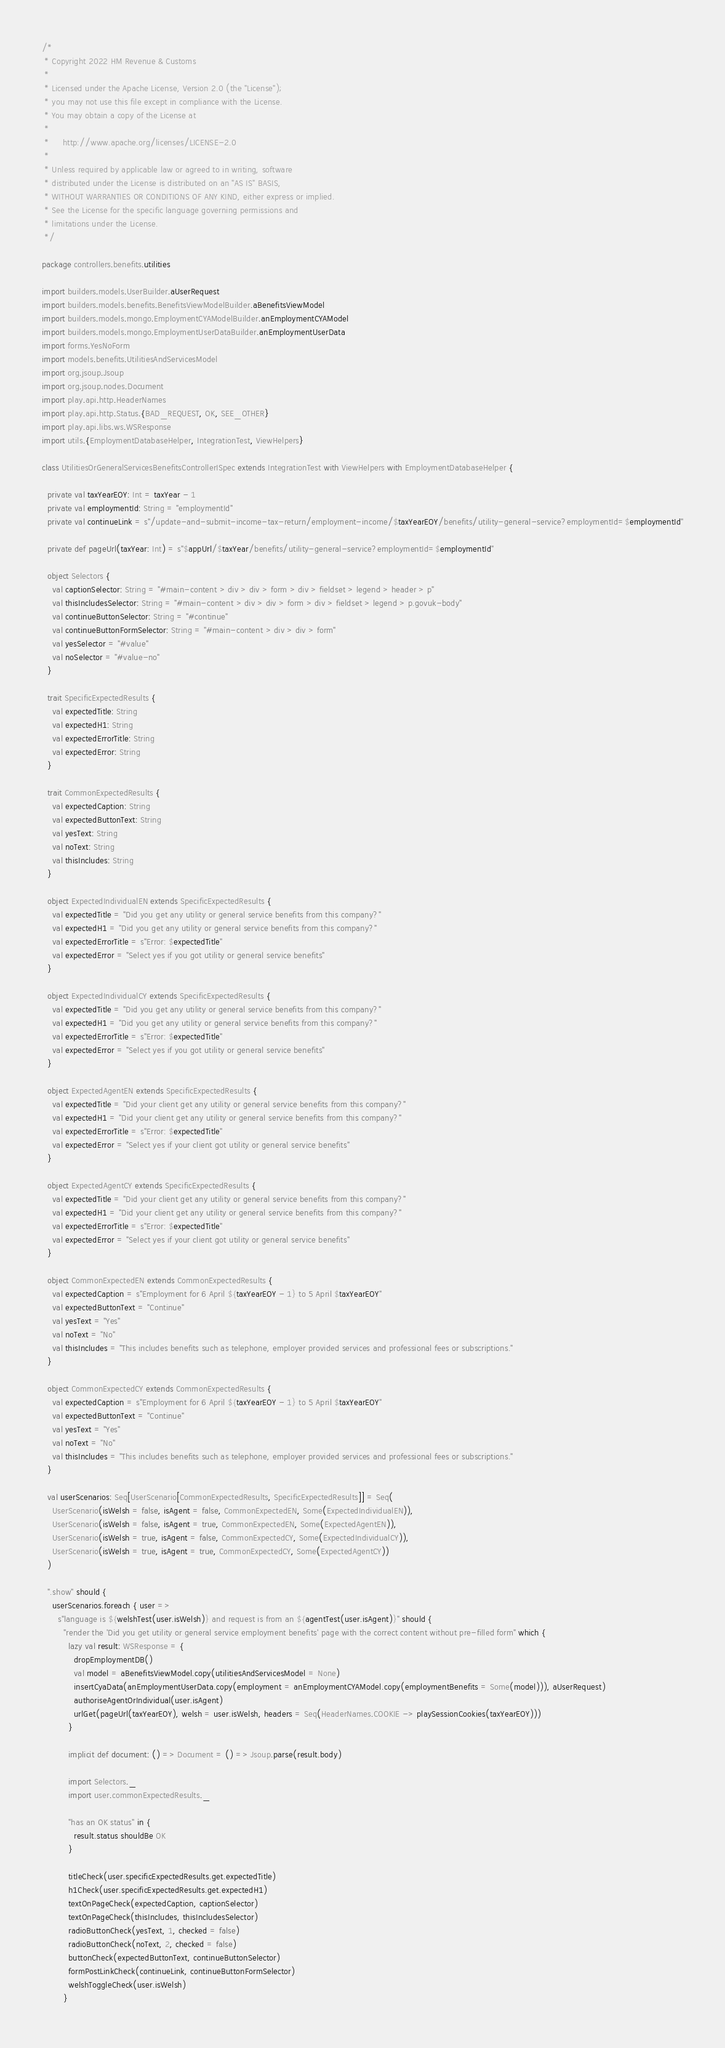<code> <loc_0><loc_0><loc_500><loc_500><_Scala_>/*
 * Copyright 2022 HM Revenue & Customs
 *
 * Licensed under the Apache License, Version 2.0 (the "License");
 * you may not use this file except in compliance with the License.
 * You may obtain a copy of the License at
 *
 *     http://www.apache.org/licenses/LICENSE-2.0
 *
 * Unless required by applicable law or agreed to in writing, software
 * distributed under the License is distributed on an "AS IS" BASIS,
 * WITHOUT WARRANTIES OR CONDITIONS OF ANY KIND, either express or implied.
 * See the License for the specific language governing permissions and
 * limitations under the License.
 */

package controllers.benefits.utilities

import builders.models.UserBuilder.aUserRequest
import builders.models.benefits.BenefitsViewModelBuilder.aBenefitsViewModel
import builders.models.mongo.EmploymentCYAModelBuilder.anEmploymentCYAModel
import builders.models.mongo.EmploymentUserDataBuilder.anEmploymentUserData
import forms.YesNoForm
import models.benefits.UtilitiesAndServicesModel
import org.jsoup.Jsoup
import org.jsoup.nodes.Document
import play.api.http.HeaderNames
import play.api.http.Status.{BAD_REQUEST, OK, SEE_OTHER}
import play.api.libs.ws.WSResponse
import utils.{EmploymentDatabaseHelper, IntegrationTest, ViewHelpers}

class UtilitiesOrGeneralServicesBenefitsControllerISpec extends IntegrationTest with ViewHelpers with EmploymentDatabaseHelper {

  private val taxYearEOY: Int = taxYear - 1
  private val employmentId: String = "employmentId"
  private val continueLink = s"/update-and-submit-income-tax-return/employment-income/$taxYearEOY/benefits/utility-general-service?employmentId=$employmentId"

  private def pageUrl(taxYear: Int) = s"$appUrl/$taxYear/benefits/utility-general-service?employmentId=$employmentId"

  object Selectors {
    val captionSelector: String = "#main-content > div > div > form > div > fieldset > legend > header > p"
    val thisIncludesSelector: String = "#main-content > div > div > form > div > fieldset > legend > p.govuk-body"
    val continueButtonSelector: String = "#continue"
    val continueButtonFormSelector: String = "#main-content > div > div > form"
    val yesSelector = "#value"
    val noSelector = "#value-no"
  }

  trait SpecificExpectedResults {
    val expectedTitle: String
    val expectedH1: String
    val expectedErrorTitle: String
    val expectedError: String
  }

  trait CommonExpectedResults {
    val expectedCaption: String
    val expectedButtonText: String
    val yesText: String
    val noText: String
    val thisIncludes: String
  }

  object ExpectedIndividualEN extends SpecificExpectedResults {
    val expectedTitle = "Did you get any utility or general service benefits from this company?"
    val expectedH1 = "Did you get any utility or general service benefits from this company?"
    val expectedErrorTitle = s"Error: $expectedTitle"
    val expectedError = "Select yes if you got utility or general service benefits"
  }

  object ExpectedIndividualCY extends SpecificExpectedResults {
    val expectedTitle = "Did you get any utility or general service benefits from this company?"
    val expectedH1 = "Did you get any utility or general service benefits from this company?"
    val expectedErrorTitle = s"Error: $expectedTitle"
    val expectedError = "Select yes if you got utility or general service benefits"
  }

  object ExpectedAgentEN extends SpecificExpectedResults {
    val expectedTitle = "Did your client get any utility or general service benefits from this company?"
    val expectedH1 = "Did your client get any utility or general service benefits from this company?"
    val expectedErrorTitle = s"Error: $expectedTitle"
    val expectedError = "Select yes if your client got utility or general service benefits"
  }

  object ExpectedAgentCY extends SpecificExpectedResults {
    val expectedTitle = "Did your client get any utility or general service benefits from this company?"
    val expectedH1 = "Did your client get any utility or general service benefits from this company?"
    val expectedErrorTitle = s"Error: $expectedTitle"
    val expectedError = "Select yes if your client got utility or general service benefits"
  }

  object CommonExpectedEN extends CommonExpectedResults {
    val expectedCaption = s"Employment for 6 April ${taxYearEOY - 1} to 5 April $taxYearEOY"
    val expectedButtonText = "Continue"
    val yesText = "Yes"
    val noText = "No"
    val thisIncludes = "This includes benefits such as telephone, employer provided services and professional fees or subscriptions."
  }

  object CommonExpectedCY extends CommonExpectedResults {
    val expectedCaption = s"Employment for 6 April ${taxYearEOY - 1} to 5 April $taxYearEOY"
    val expectedButtonText = "Continue"
    val yesText = "Yes"
    val noText = "No"
    val thisIncludes = "This includes benefits such as telephone, employer provided services and professional fees or subscriptions."
  }

  val userScenarios: Seq[UserScenario[CommonExpectedResults, SpecificExpectedResults]] = Seq(
    UserScenario(isWelsh = false, isAgent = false, CommonExpectedEN, Some(ExpectedIndividualEN)),
    UserScenario(isWelsh = false, isAgent = true, CommonExpectedEN, Some(ExpectedAgentEN)),
    UserScenario(isWelsh = true, isAgent = false, CommonExpectedCY, Some(ExpectedIndividualCY)),
    UserScenario(isWelsh = true, isAgent = true, CommonExpectedCY, Some(ExpectedAgentCY))
  )

  ".show" should {
    userScenarios.foreach { user =>
      s"language is ${welshTest(user.isWelsh)} and request is from an ${agentTest(user.isAgent)}" should {
        "render the 'Did you get utility or general service employment benefits' page with the correct content without pre-filled form" which {
          lazy val result: WSResponse = {
            dropEmploymentDB()
            val model = aBenefitsViewModel.copy(utilitiesAndServicesModel = None)
            insertCyaData(anEmploymentUserData.copy(employment = anEmploymentCYAModel.copy(employmentBenefits = Some(model))), aUserRequest)
            authoriseAgentOrIndividual(user.isAgent)
            urlGet(pageUrl(taxYearEOY), welsh = user.isWelsh, headers = Seq(HeaderNames.COOKIE -> playSessionCookies(taxYearEOY)))
          }

          implicit def document: () => Document = () => Jsoup.parse(result.body)

          import Selectors._
          import user.commonExpectedResults._

          "has an OK status" in {
            result.status shouldBe OK
          }

          titleCheck(user.specificExpectedResults.get.expectedTitle)
          h1Check(user.specificExpectedResults.get.expectedH1)
          textOnPageCheck(expectedCaption, captionSelector)
          textOnPageCheck(thisIncludes, thisIncludesSelector)
          radioButtonCheck(yesText, 1, checked = false)
          radioButtonCheck(noText, 2, checked = false)
          buttonCheck(expectedButtonText, continueButtonSelector)
          formPostLinkCheck(continueLink, continueButtonFormSelector)
          welshToggleCheck(user.isWelsh)
        }
</code> 